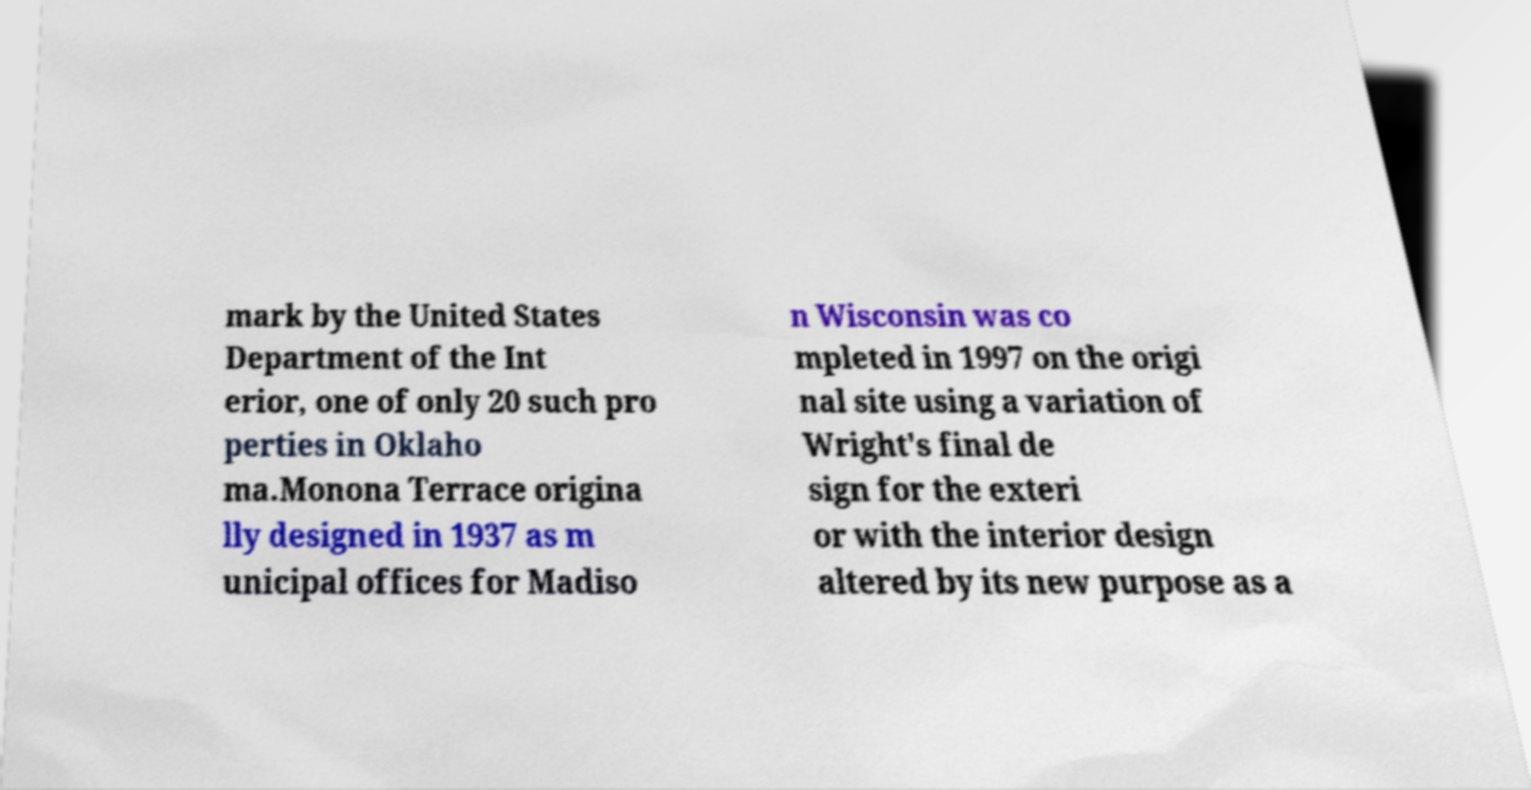For documentation purposes, I need the text within this image transcribed. Could you provide that? mark by the United States Department of the Int erior, one of only 20 such pro perties in Oklaho ma.Monona Terrace origina lly designed in 1937 as m unicipal offices for Madiso n Wisconsin was co mpleted in 1997 on the origi nal site using a variation of Wright's final de sign for the exteri or with the interior design altered by its new purpose as a 